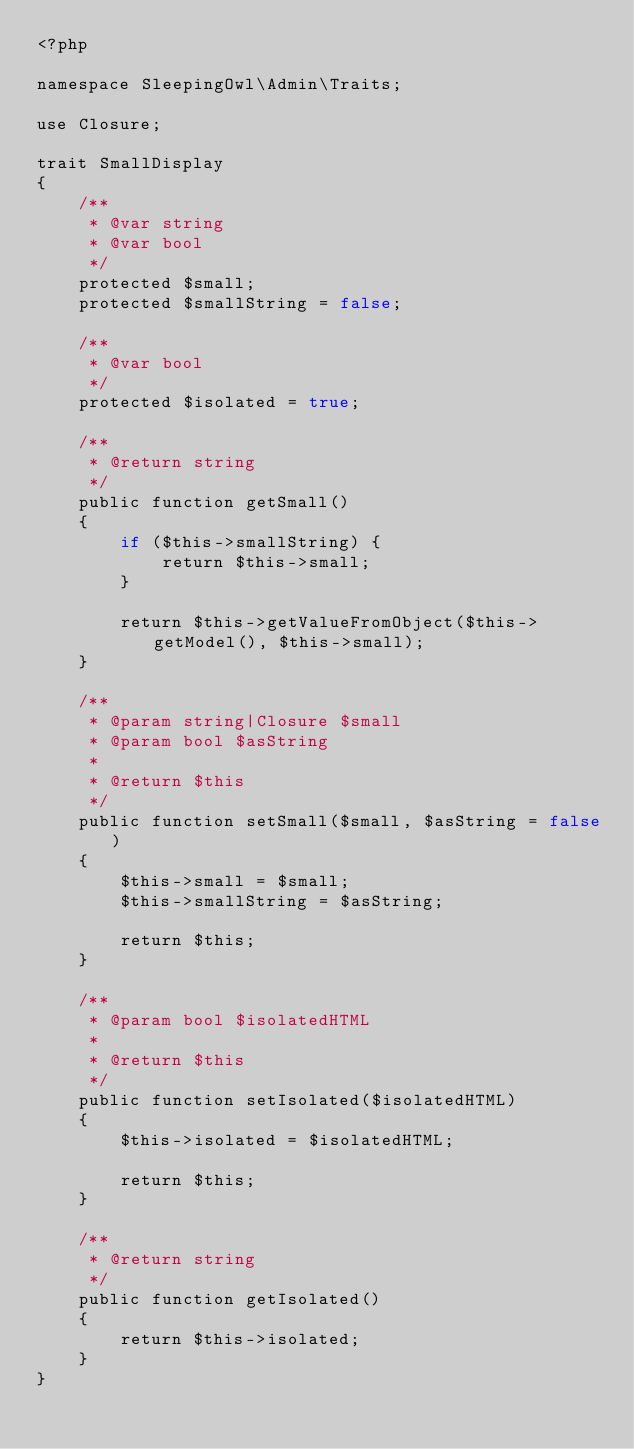Convert code to text. <code><loc_0><loc_0><loc_500><loc_500><_PHP_><?php

namespace SleepingOwl\Admin\Traits;

use Closure;

trait SmallDisplay
{
    /**
     * @var string
     * @var bool
     */
    protected $small;
    protected $smallString = false;

    /**
     * @var bool
     */
    protected $isolated = true;

    /**
     * @return string
     */
    public function getSmall()
    {
        if ($this->smallString) {
            return $this->small;
        }

        return $this->getValueFromObject($this->getModel(), $this->small);
    }

    /**
     * @param string|Closure $small
     * @param bool $asString
     *
     * @return $this
     */
    public function setSmall($small, $asString = false)
    {
        $this->small = $small;
        $this->smallString = $asString;

        return $this;
    }

    /**
     * @param bool $isolatedHTML
     *
     * @return $this
     */
    public function setIsolated($isolatedHTML)
    {
        $this->isolated = $isolatedHTML;

        return $this;
    }

    /**
     * @return string
     */
    public function getIsolated()
    {
        return $this->isolated;
    }
}
</code> 